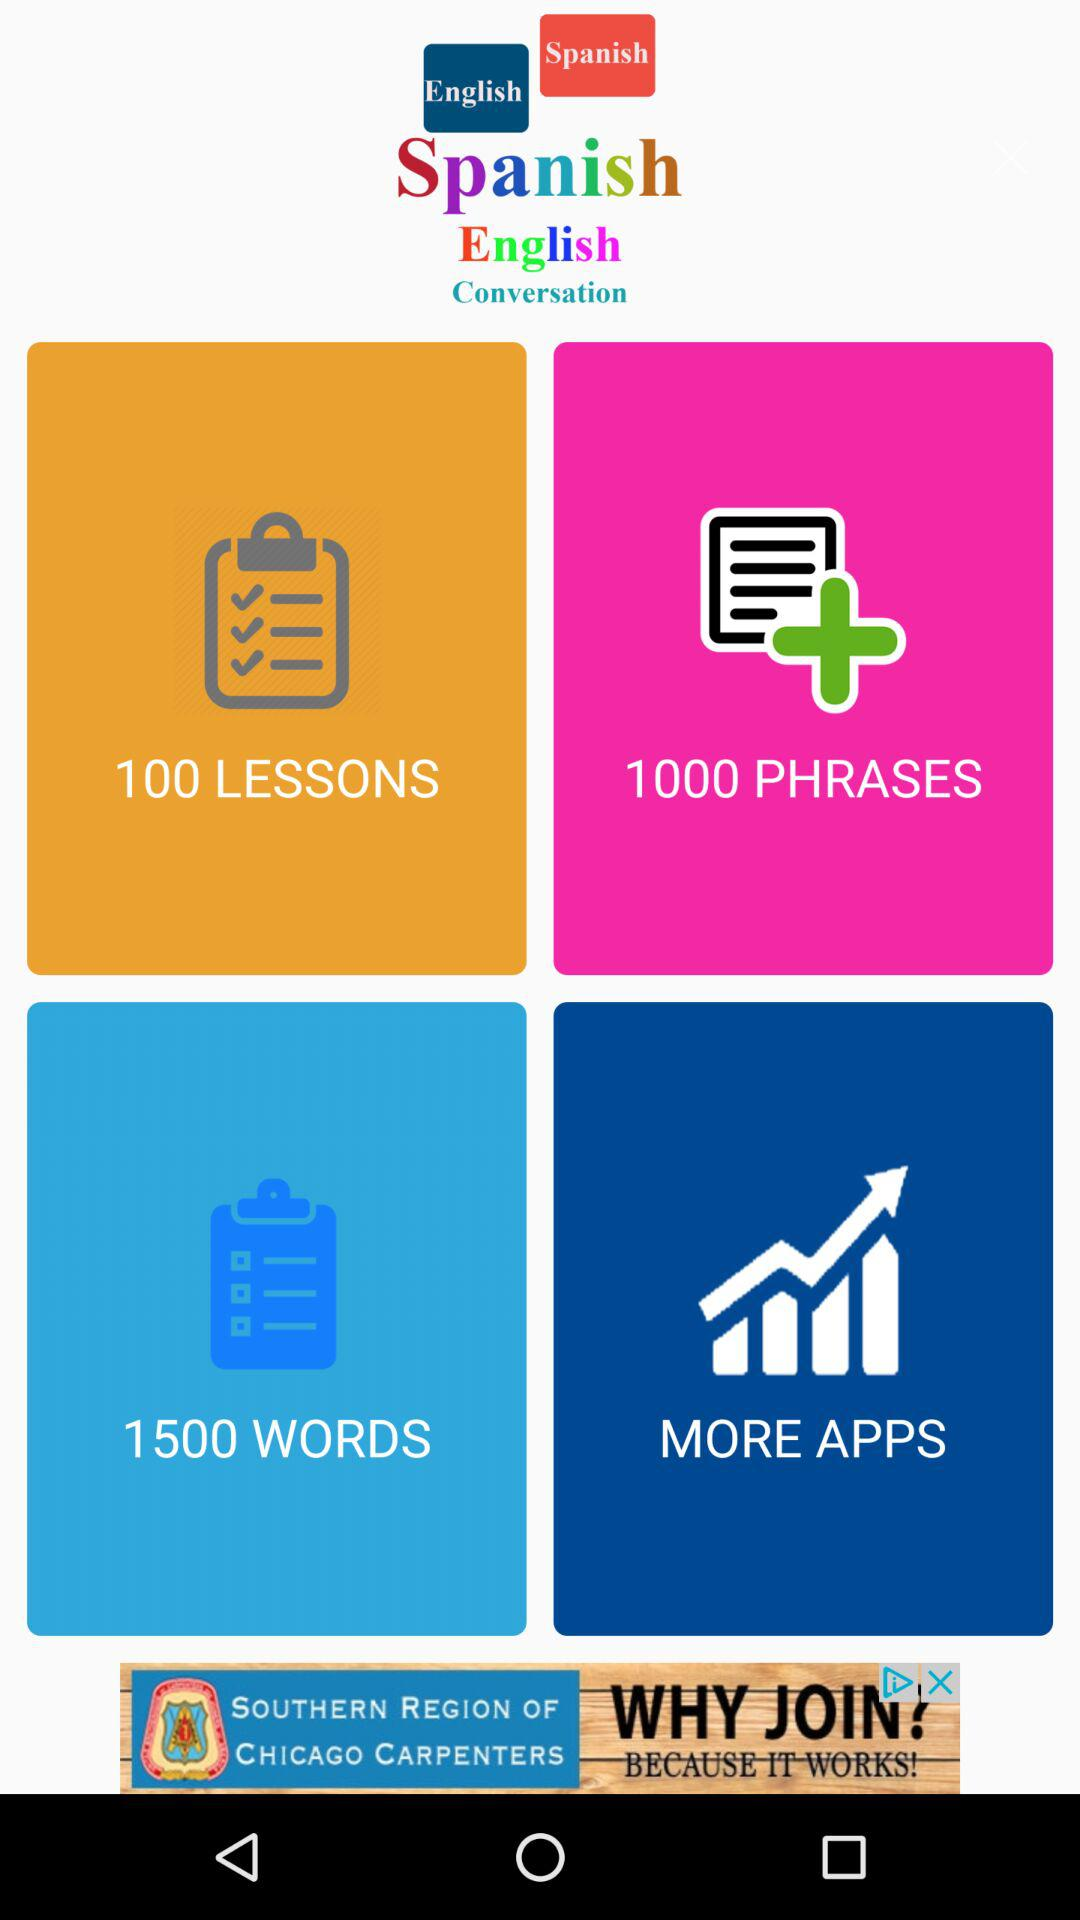How many lessons are there? There are 100 lessons. 